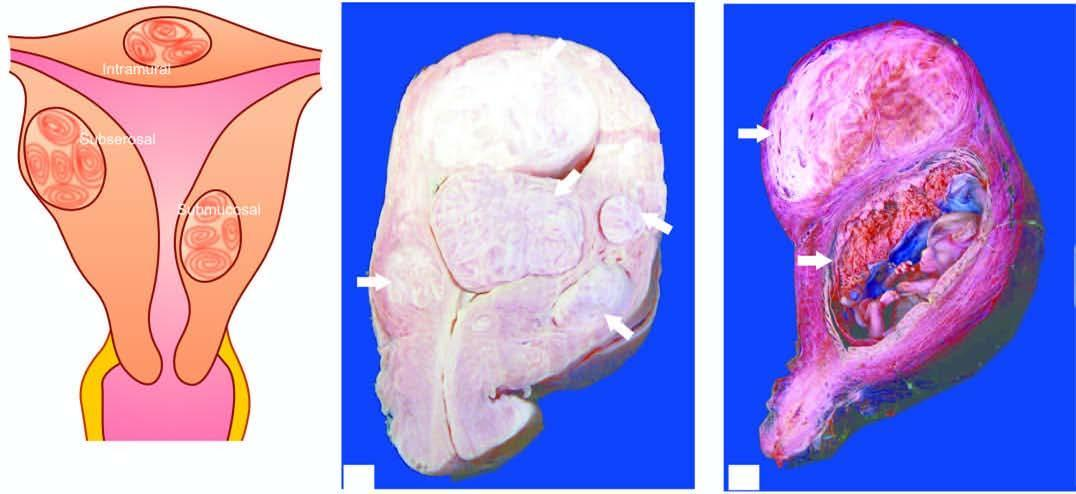what shows multiple circumscribed, firm nodular masses of variable sizes-submucosal in location having characteristic whorling?
Answer the question using a single word or phrase. Sectioned surface of the uterus 